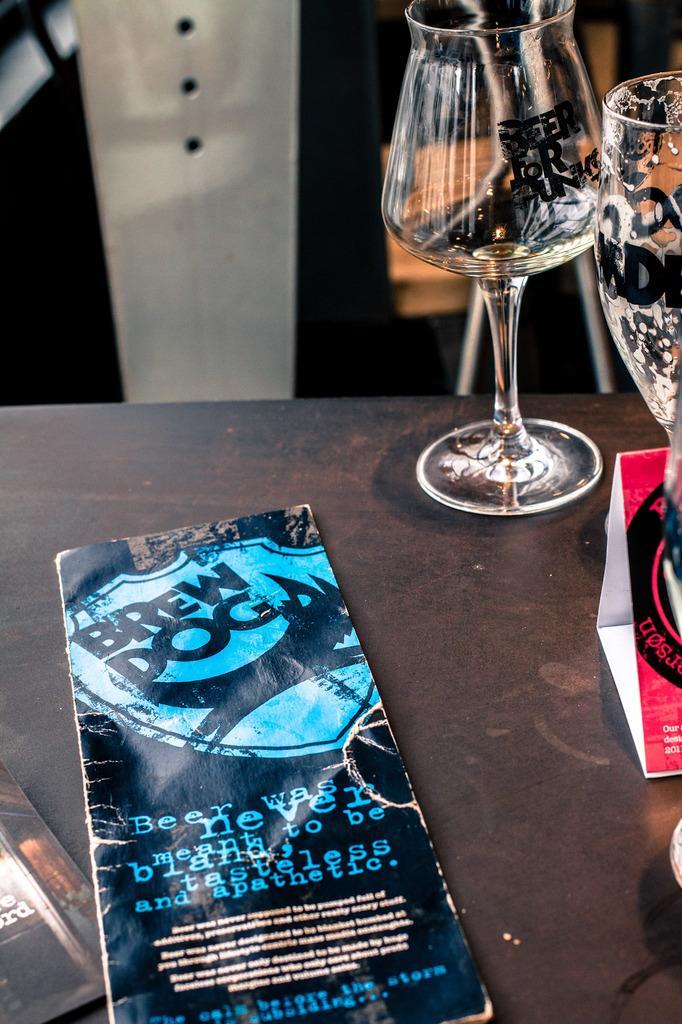Could you give a brief overview of what you see in this image? In this image we can see many objects on a table. Behind the table, we can see few objects. 